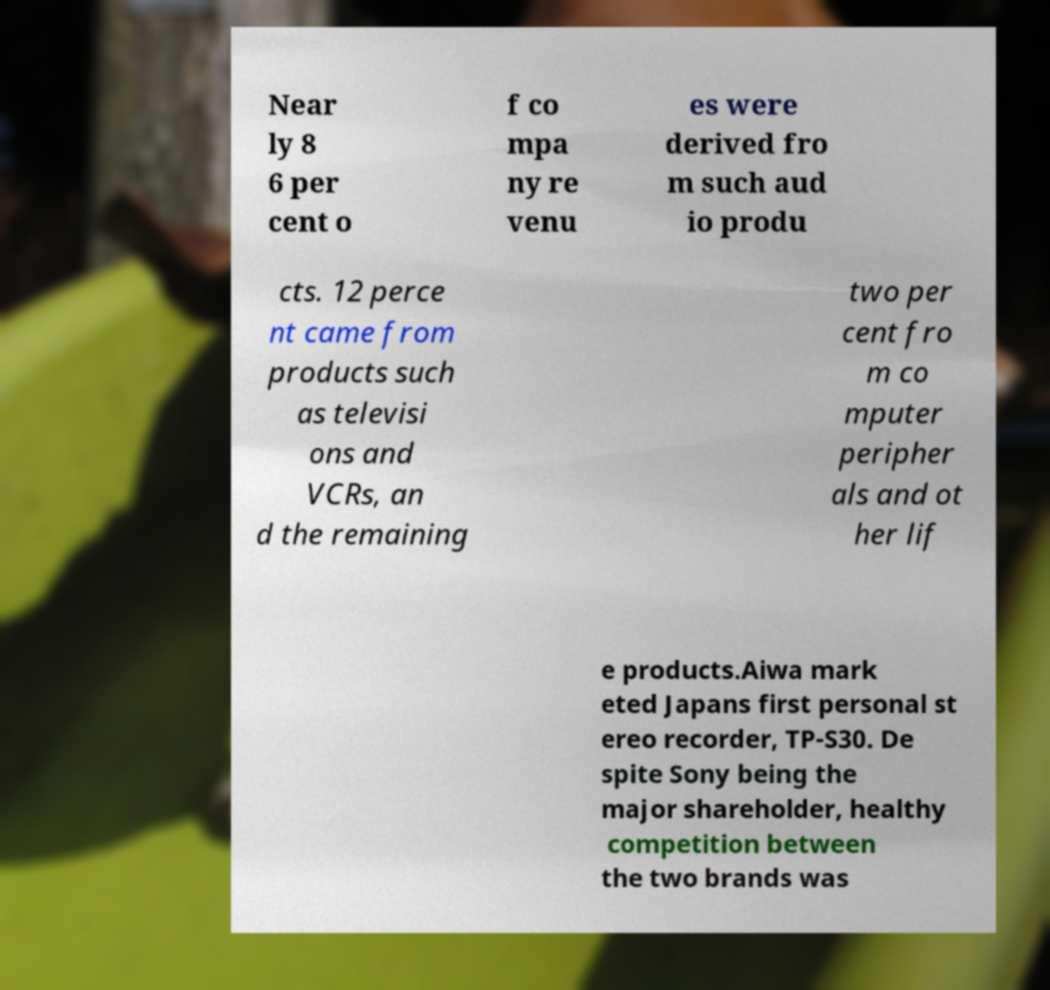For documentation purposes, I need the text within this image transcribed. Could you provide that? Near ly 8 6 per cent o f co mpa ny re venu es were derived fro m such aud io produ cts. 12 perce nt came from products such as televisi ons and VCRs, an d the remaining two per cent fro m co mputer peripher als and ot her lif e products.Aiwa mark eted Japans first personal st ereo recorder, TP-S30. De spite Sony being the major shareholder, healthy competition between the two brands was 